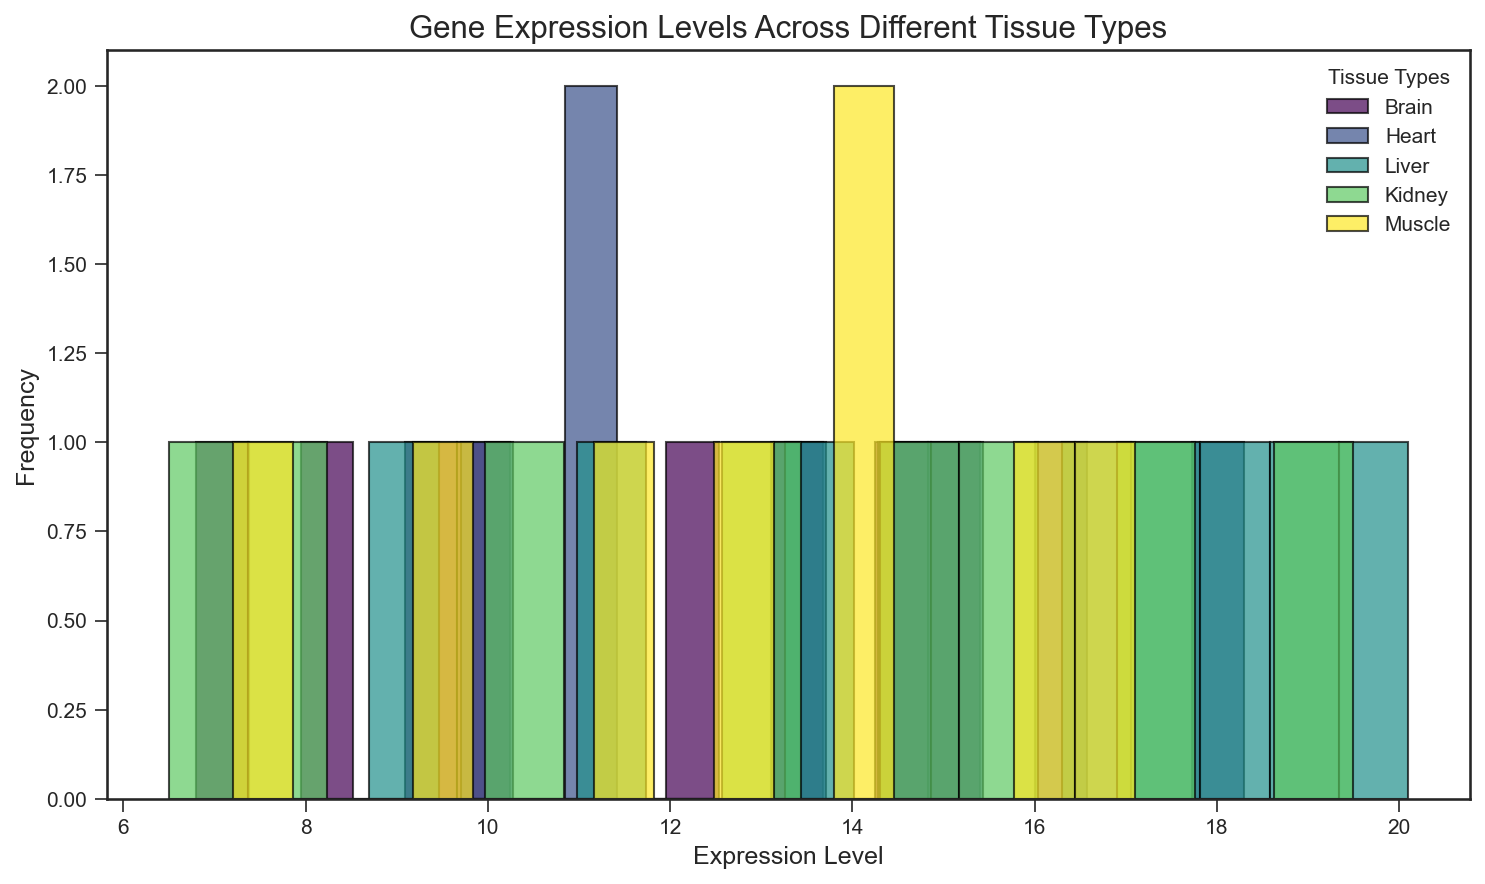Which tissue type has the highest frequency of gene expression levels? To answer this, observe the histogram and look for the tallest bar across all tissue types. The tissue type represented by this bar will have the highest frequency.
Answer: Tissue type with the highest bar Which tissue type has more samples with lower gene expression levels? Look at the histogram bars for each tissue type on the lower end of the expression level axis (left side). The tissue type with more bars in this range has more samples with lower gene expression levels.
Answer: Tissue type with more bars on the left Which tissue type(s) have the most evenly distributed gene expression levels? Observe the spread and the height of the bars for each tissue type. The tissue types with bars of almost equal height across the range of expression levels are more evenly distributed.
Answer: Tissue types with bars of similar height Which tissue type appears to have the highest variability in gene expression levels? Look for the tissue type with the widest spread (bars spread out) across the expression level axis. Higher variability means a wider range of expression levels.
Answer: Tissue type with the widest spread Are there more high frequency low expression levels in the Brain or the Muscle tissue type? Compare the leftmost bars (lower expression levels) for both Brain and Muscle. The tissue with taller bars in this range has more high-frequency low expression levels.
Answer: Check the taller bars between Brain and Muscle on the left side Does the Heart tissue have any unique expression patterns compared to other tissues? Look at the histogram for Heart and compare the shape and spread of its bars to the other tissue types. Note any distinct features like peaks at specific expression levels or overall distribution pattern.
Answer: Observations of distinct features in Heart Which tissue type has the closest average gene expression level to 10? Identify the tissue type whose bars cluster closer to the 10 mark on the expression level axis. This indicates an average expression level near 10.
Answer: Tissue type with bars clustering around 10 How do the expression levels in Kidney compare to those in Liver? Compare the histograms for Kidney and Liver. Look at the height and spread of bars for both tissue types to understand the differences in expression levels.
Answer: Comparative observation between Kidney and Liver Which tissue type has a more predominant high gene expression levels? Check the rightmost bars (higher expression levels) for each tissue type. The tissue type with taller bars in this range shows a predominance of high gene expression levels.
Answer: Tissue type with taller bars on the right side 